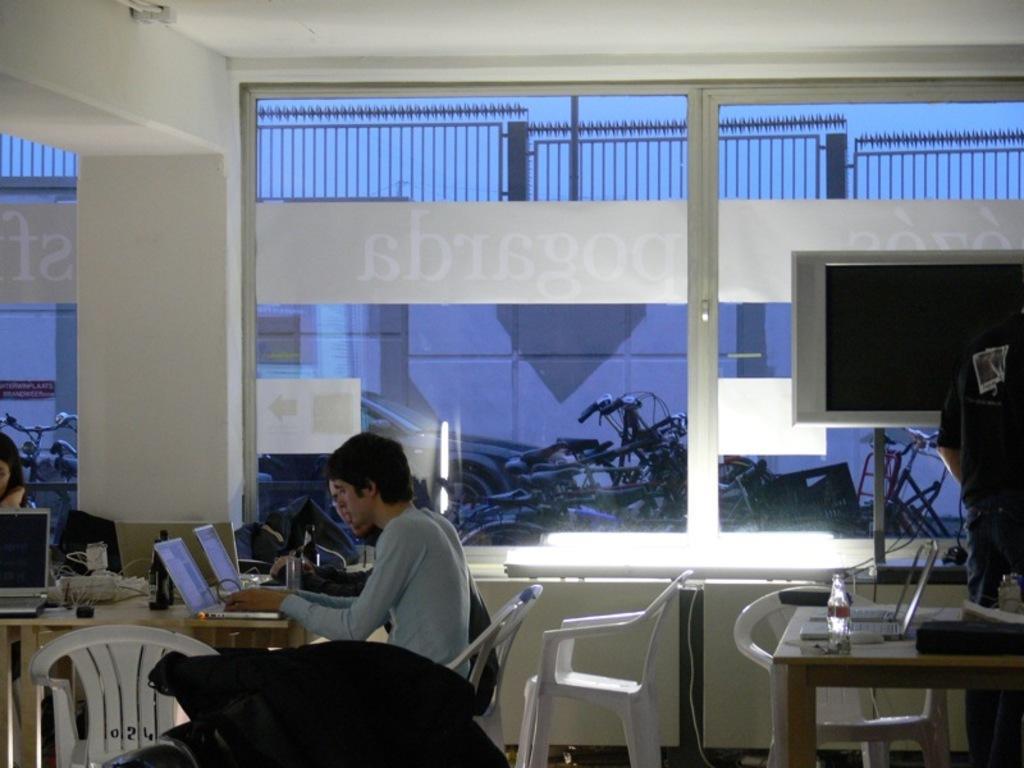Could you give a brief overview of what you see in this image? In this image there are 2 persons sitting near a table and operating laptop, there is v=chair, cables, building , bicycle, car, television , bottle, laptop. 